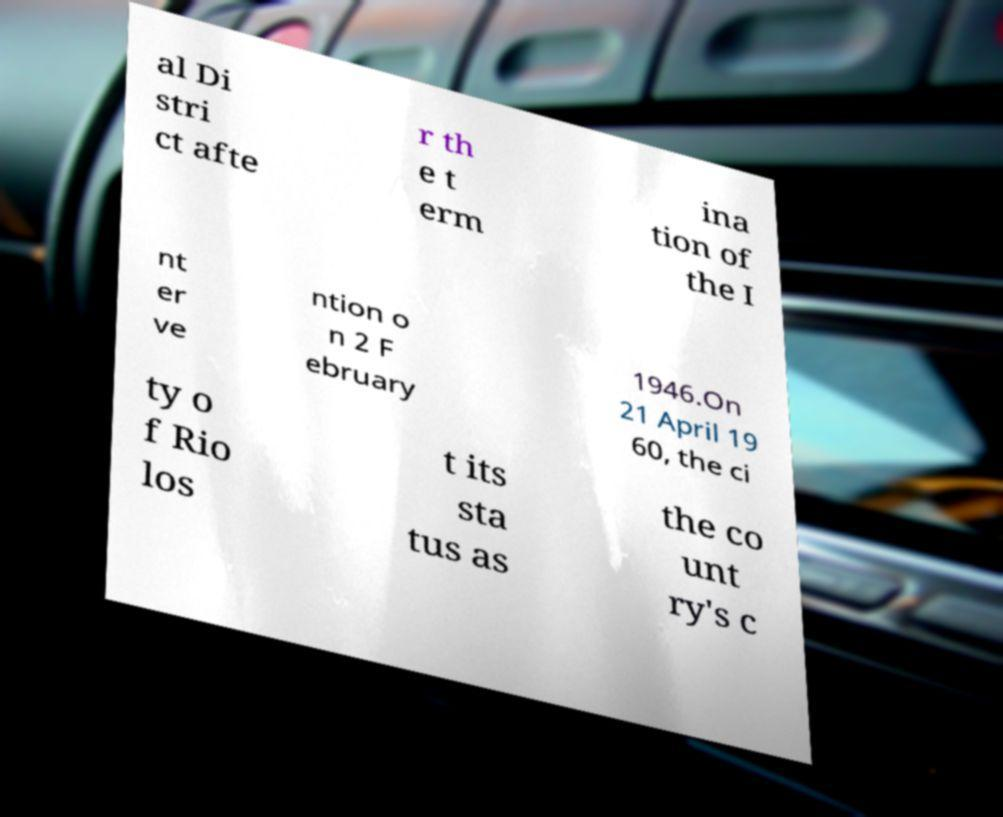What messages or text are displayed in this image? I need them in a readable, typed format. al Di stri ct afte r th e t erm ina tion of the I nt er ve ntion o n 2 F ebruary 1946.On 21 April 19 60, the ci ty o f Rio los t its sta tus as the co unt ry's c 